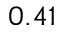Convert formula to latex. <formula><loc_0><loc_0><loc_500><loc_500>0 . 4 1</formula> 